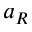<formula> <loc_0><loc_0><loc_500><loc_500>a _ { R }</formula> 